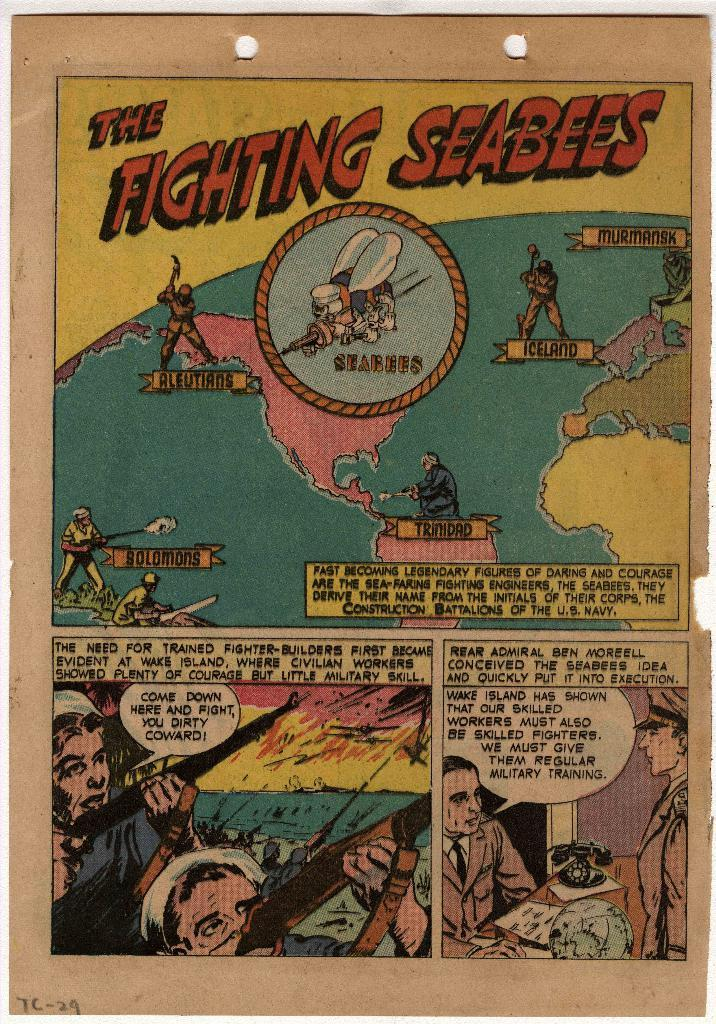Provide a one-sentence caption for the provided image. an old comic book page titled the fighting seabees. 